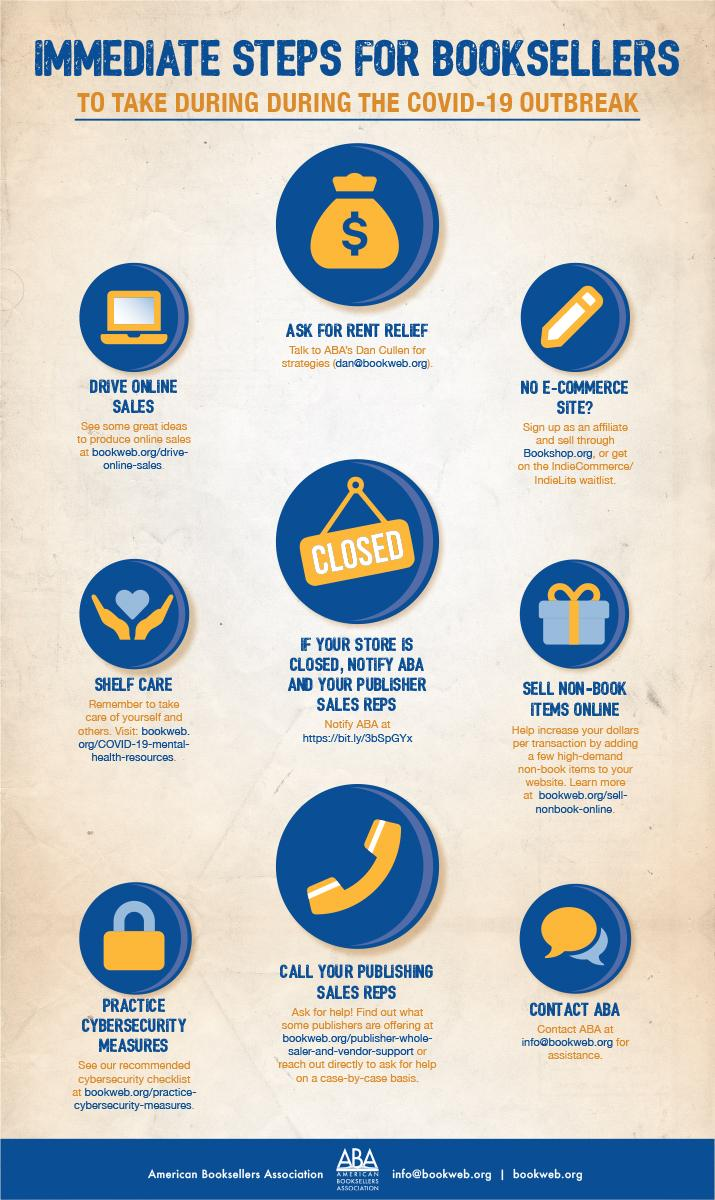Identify some key points in this picture. During the COVID-19 outbreak, booksellers have had to take a significant number of steps in order to comply with safety protocols and prevent the spread of the virus. Specifically, it is reported that booksellers have had to take at least 9 steps in order to ensure the safety of their businesses and customers. 